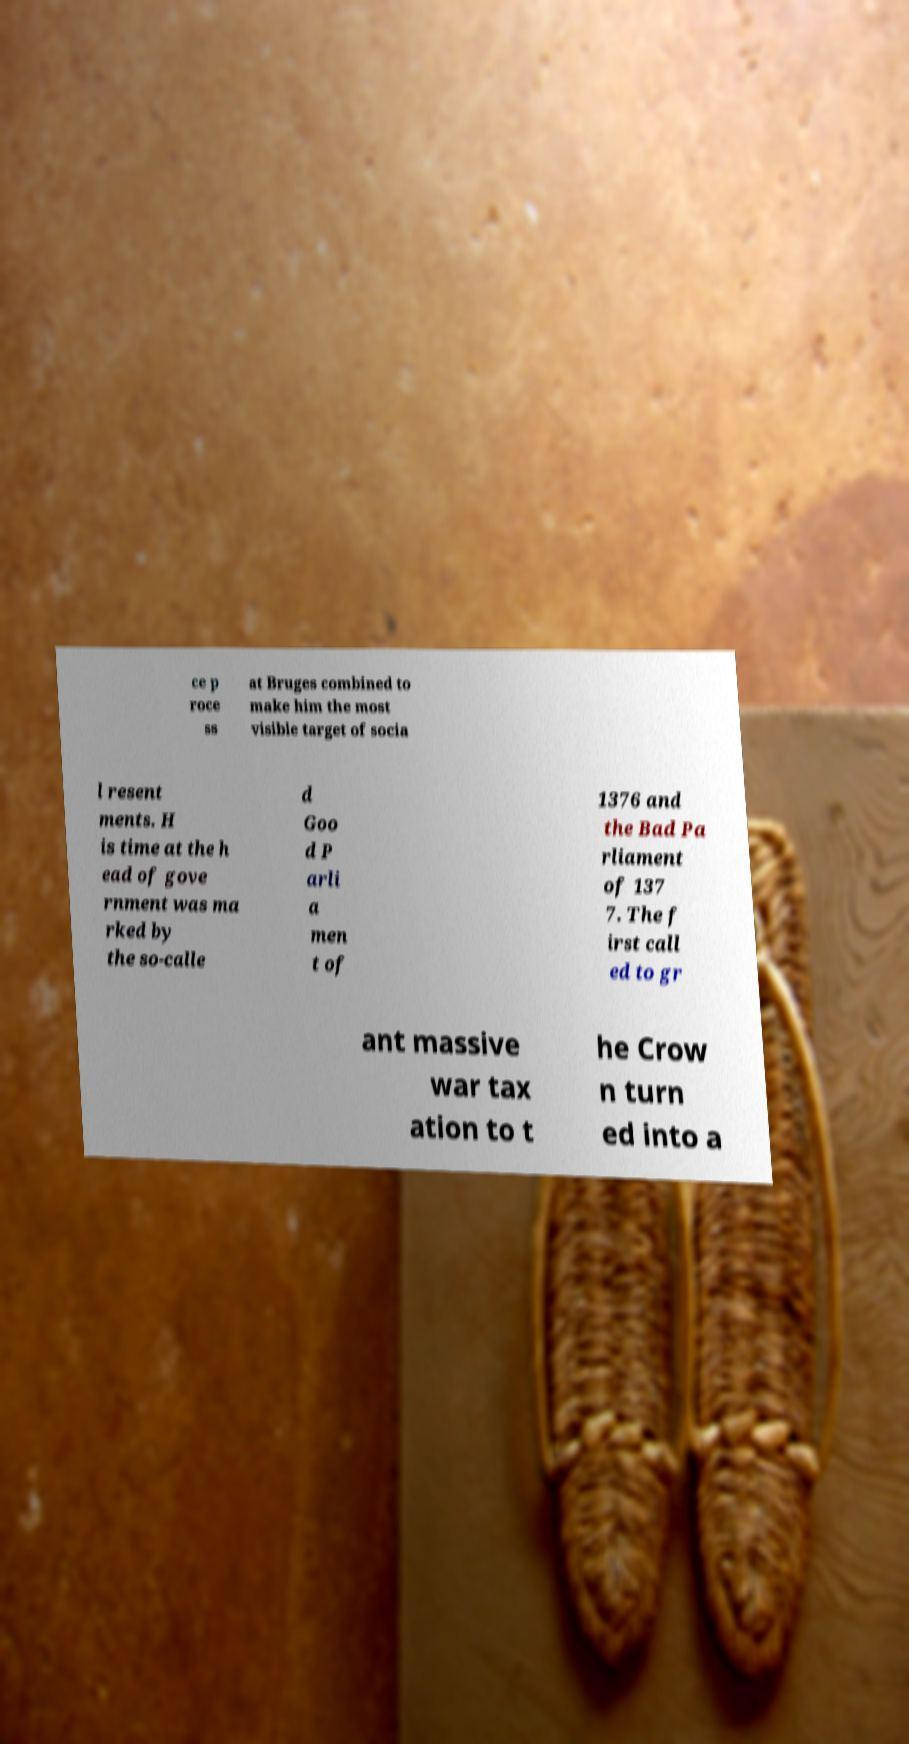Could you extract and type out the text from this image? ce p roce ss at Bruges combined to make him the most visible target of socia l resent ments. H is time at the h ead of gove rnment was ma rked by the so-calle d Goo d P arli a men t of 1376 and the Bad Pa rliament of 137 7. The f irst call ed to gr ant massive war tax ation to t he Crow n turn ed into a 